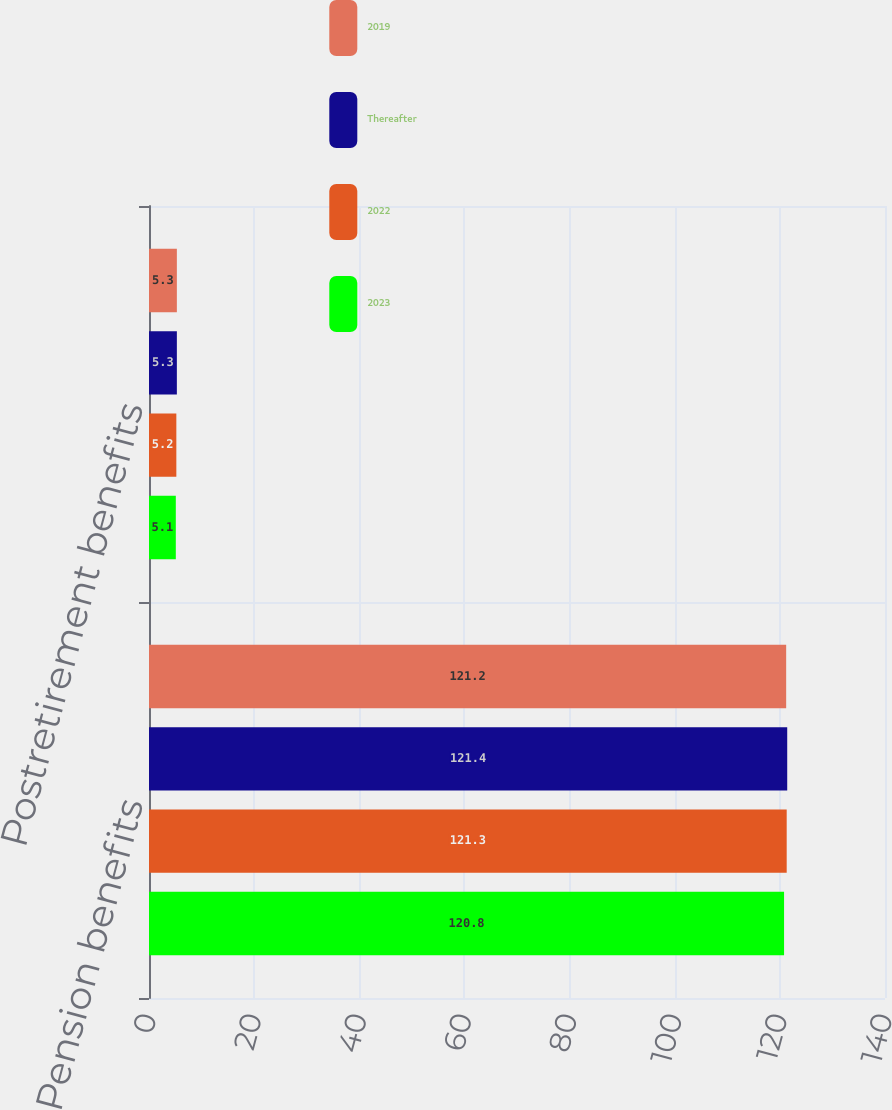<chart> <loc_0><loc_0><loc_500><loc_500><stacked_bar_chart><ecel><fcel>Pension benefits<fcel>Postretirement benefits<nl><fcel>2019<fcel>121.2<fcel>5.3<nl><fcel>Thereafter<fcel>121.4<fcel>5.3<nl><fcel>2022<fcel>121.3<fcel>5.2<nl><fcel>2023<fcel>120.8<fcel>5.1<nl></chart> 